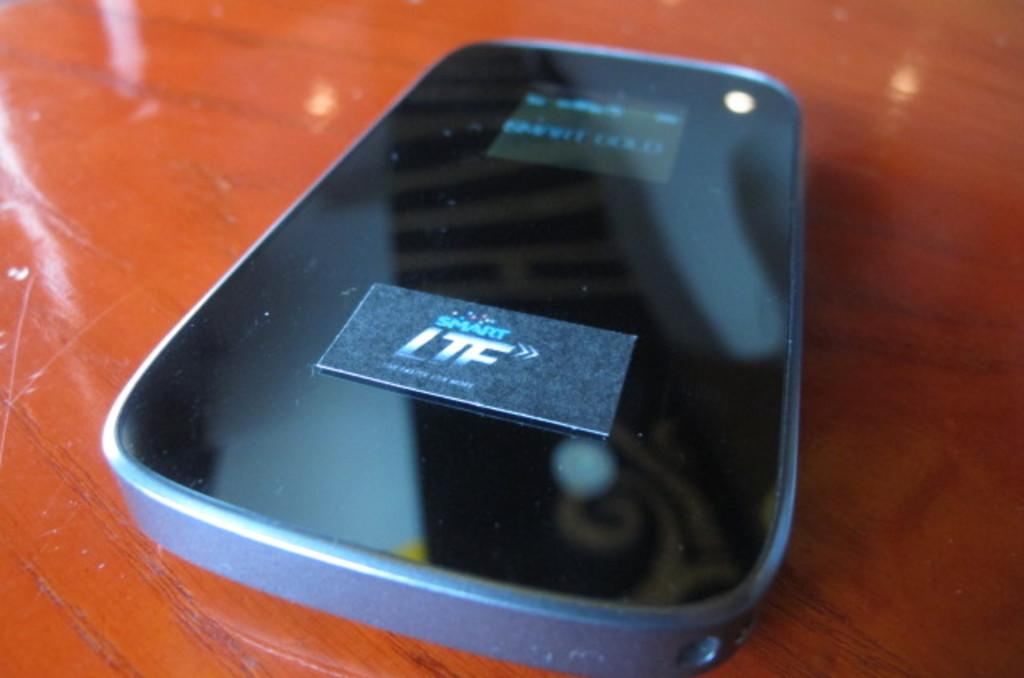<image>
Write a terse but informative summary of the picture. AN LTF logo is on the screen of a phone. 